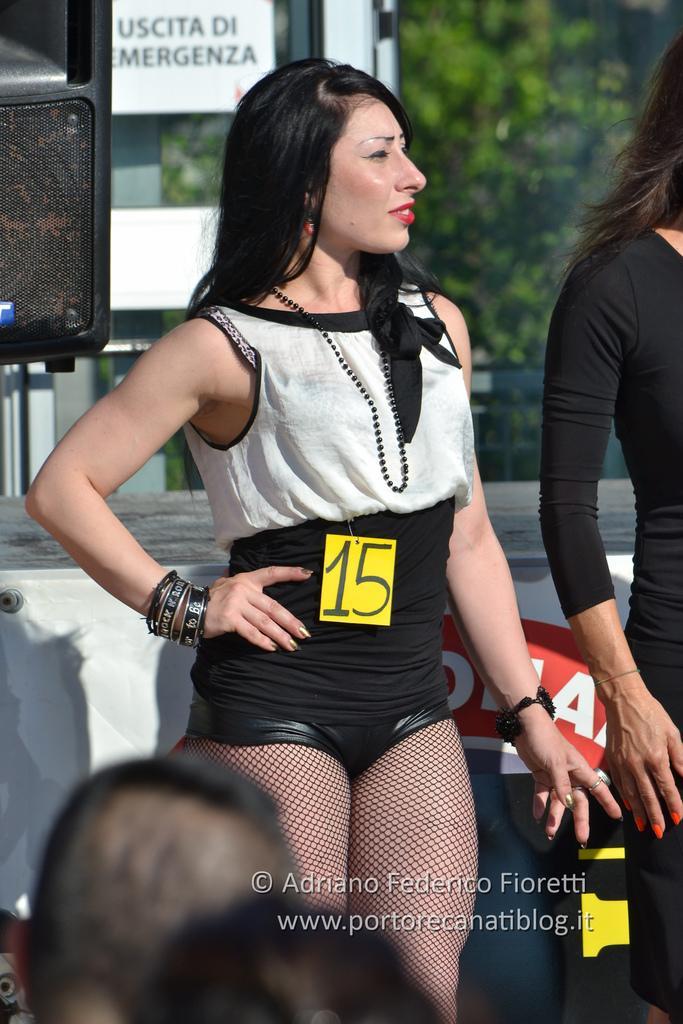Describe this image in one or two sentences. In this image there are persons. In the background there are objects and there are trees and there is a board with some text written on it and there is some text written at the bottom of the image. 